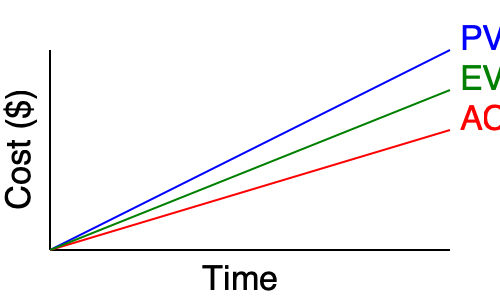As a project manager working closely with your foreman to meet deadlines, you're analyzing the Earned Value Management (EVM) graph for your current project. At the latest reporting point, what is the Schedule Performance Index (SPI), and what does it indicate about the project's schedule status? To determine the Schedule Performance Index (SPI) and interpret the project's schedule status, we'll follow these steps:

1. Identify the key components in the EVM graph:
   - Blue line: Planned Value (PV)
   - Red line: Actual Cost (AC)
   - Green line: Earned Value (EV)

2. Calculate SPI using the formula:
   $$ SPI = \frac{EV}{PV} $$

3. At the latest reporting point (rightmost point on the graph):
   - EV ≈ $410,000
   - PV ≈ $450,000

4. Calculate SPI:
   $$ SPI = \frac{410,000}{450,000} \approx 0.91 $$

5. Interpret the SPI value:
   - SPI < 1 indicates the project is behind schedule
   - SPI = 1 indicates the project is on schedule
   - SPI > 1 indicates the project is ahead of schedule

6. With an SPI of 0.91, the project is behind schedule. Specifically:
   - The project has completed 91% of the work planned for this point in time.
   - The project is approximately 9% behind schedule.

As a project manager working with your foreman, this information suggests you need to discuss strategies to accelerate the project's progress to meet the planned deadlines.
Answer: SPI ≈ 0.91; project is behind schedule. 